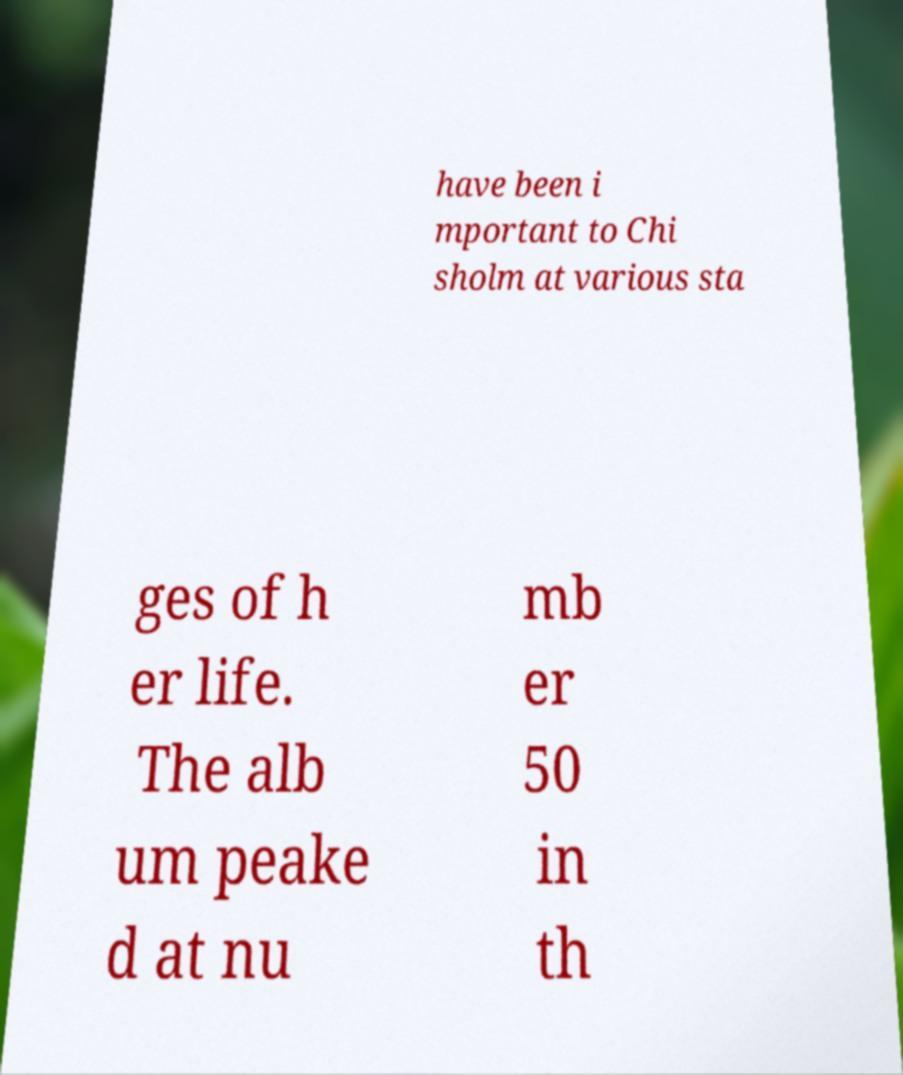Please identify and transcribe the text found in this image. have been i mportant to Chi sholm at various sta ges of h er life. The alb um peake d at nu mb er 50 in th 